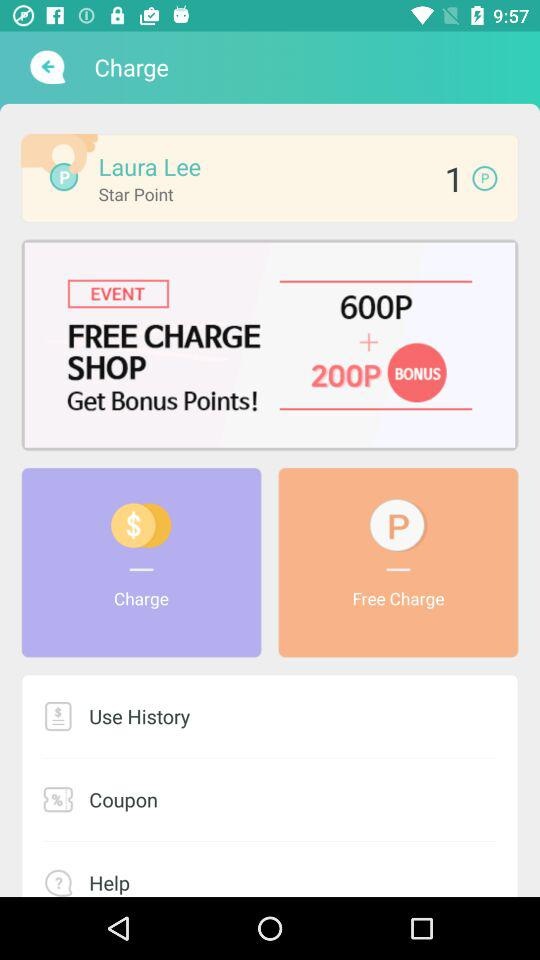How many coupons are there?
When the provided information is insufficient, respond with <no answer>. <no answer> 